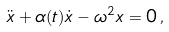Convert formula to latex. <formula><loc_0><loc_0><loc_500><loc_500>\ddot { x } + \alpha ( t ) \dot { x } - \omega ^ { 2 } x = 0 \, ,</formula> 